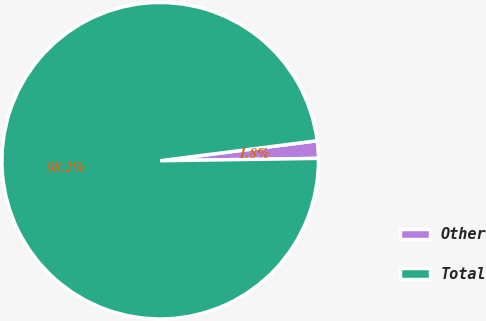<chart> <loc_0><loc_0><loc_500><loc_500><pie_chart><fcel>Other<fcel>Total<nl><fcel>1.78%<fcel>98.22%<nl></chart> 